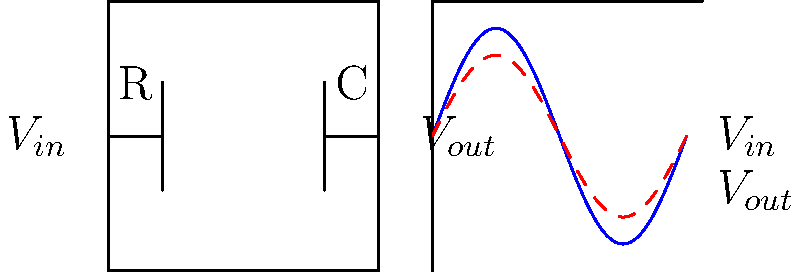In the RC low-pass filter circuit shown, the input voltage $V_{in}$ is a sinusoidal signal with a frequency of 1 kHz and an amplitude of 5V. If the resistance R is 10 kΩ and the capacitance C is 15 nF, calculate the cutoff frequency of the filter. How does this relate to John Kerry's campaign strategy of "reaching across the aisle" during the 2004 presidential race? Let's approach this step-by-step:

1) The cutoff frequency for a low-pass RC filter is given by the formula:

   $$f_c = \frac{1}{2\pi RC}$$

2) We're given:
   R = 10 kΩ = 10,000 Ω
   C = 15 nF = 15 × 10^-9 F

3) Substituting these values into the formula:

   $$f_c = \frac{1}{2\pi (10,000)(15 × 10^{-9})}$$

4) Simplifying:

   $$f_c = \frac{1}{2\pi (150 × 10^{-6})} = \frac{10^6}{300\pi} \approx 1061 \text{ Hz}$$

5) Relating to John Kerry's 2004 campaign:
   Just as this low-pass filter allows lower frequencies to pass while attenuating higher frequencies, Kerry's "reaching across the aisle" strategy aimed to filter out partisan noise and focus on core issues. The cutoff frequency of about 1 kHz represents a balance point, similar to Kerry's attempt to balance appealing to both Democrats and moderate Republicans.
Answer: 1061 Hz; represents Kerry's balanced approach in 2004 